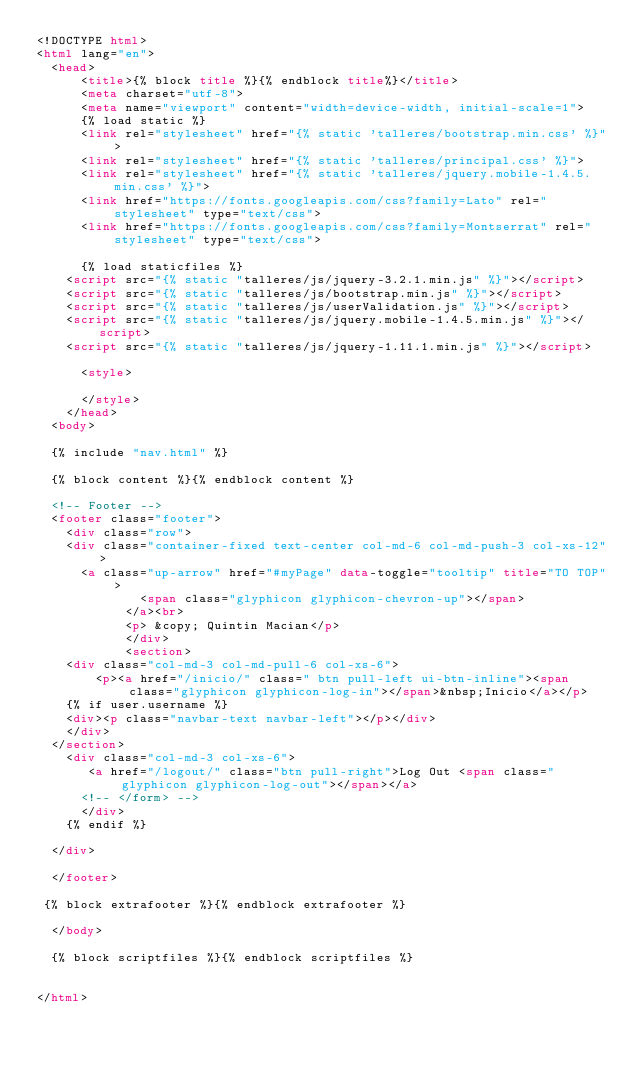<code> <loc_0><loc_0><loc_500><loc_500><_HTML_><!DOCTYPE html>
<html lang="en">
  <head>
      <title>{% block title %}{% endblock title%}</title>
      <meta charset="utf-8">
      <meta name="viewport" content="width=device-width, initial-scale=1">
      {% load static %}
      <link rel="stylesheet" href="{% static 'talleres/bootstrap.min.css' %}">
      <link rel="stylesheet" href="{% static 'talleres/principal.css' %}">
      <link rel="stylesheet" href="{% static 'talleres/jquery.mobile-1.4.5.min.css' %}">
      <link href="https://fonts.googleapis.com/css?family=Lato" rel="stylesheet" type="text/css">
      <link href="https://fonts.googleapis.com/css?family=Montserrat" rel="stylesheet" type="text/css">
      
      {% load staticfiles %}
    <script src="{% static "talleres/js/jquery-3.2.1.min.js" %}"></script>
    <script src="{% static "talleres/js/bootstrap.min.js" %}"></script>
    <script src="{% static "talleres/js/userValidation.js" %}"></script>
    <script src="{% static "talleres/js/jquery.mobile-1.4.5.min.js" %}"></script>
    <script src="{% static "talleres/js/jquery-1.11.1.min.js" %}"></script>

      <style>
      
      </style>
    </head>
  <body>

  {% include "nav.html" %}

  {% block content %}{% endblock content %}

  <!-- Footer -->
  <footer class="footer">
    <div class="row">
    <div class="container-fixed text-center col-md-6 col-md-push-3 col-xs-12">
      <a class="up-arrow" href="#myPage" data-toggle="tooltip" title="TO TOP">
              <span class="glyphicon glyphicon-chevron-up"></span>
            </a><br>
            <p> &copy; Quintin Macian</p>
            </div>
            <section>    
    <div class="col-md-3 col-md-pull-6 col-xs-6">
        <p><a href="/inicio/" class=" btn pull-left ui-btn-inline"><span class="glyphicon glyphicon-log-in"></span>&nbsp;Inicio</a></p>
    {% if user.username %}
    <div><p class="navbar-text navbar-left"></p></div>
    </div>
  </section>
    <div class="col-md-3 col-xs-6">
       <a href="/logout/" class="btn pull-right">Log Out <span class="glyphicon glyphicon-log-out"></span></a>
      <!-- </form> -->
      </div>
    {% endif %}

  </div>

  </footer>

 {% block extrafooter %}{% endblock extrafooter %}
 
  </body>

  {% block scriptfiles %}{% endblock scriptfiles %}
  

</html></code> 